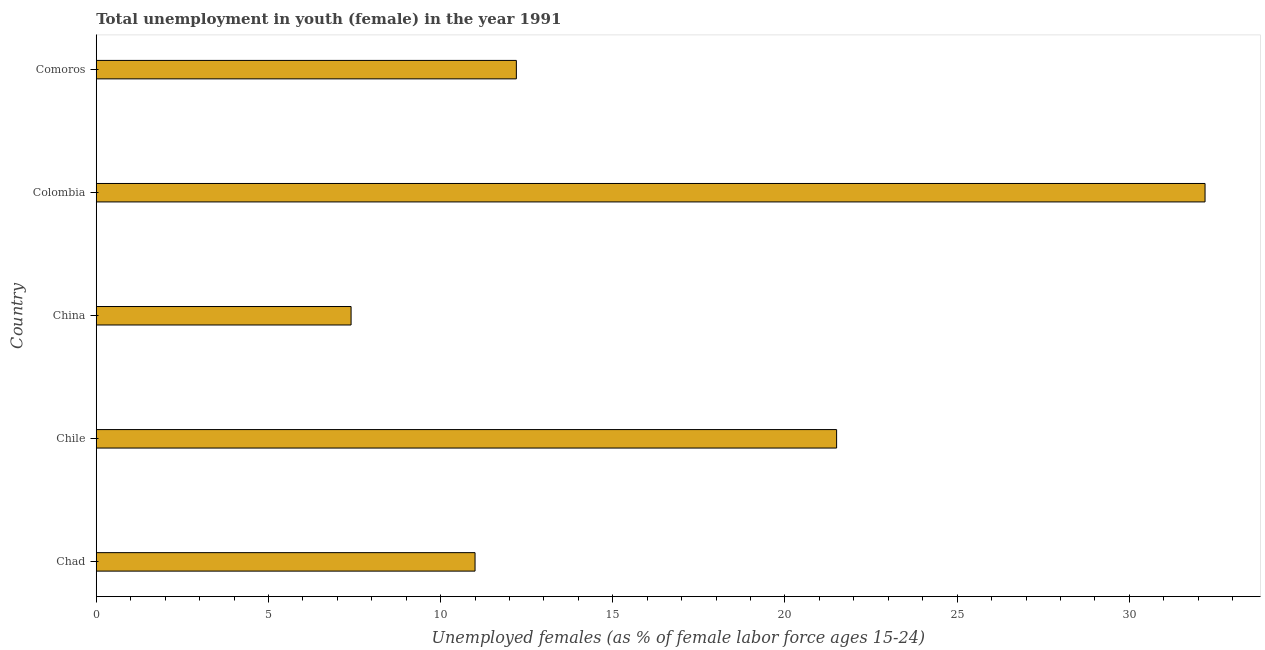Does the graph contain any zero values?
Provide a succinct answer. No. Does the graph contain grids?
Offer a very short reply. No. What is the title of the graph?
Offer a terse response. Total unemployment in youth (female) in the year 1991. What is the label or title of the X-axis?
Your answer should be compact. Unemployed females (as % of female labor force ages 15-24). What is the label or title of the Y-axis?
Ensure brevity in your answer.  Country. What is the unemployed female youth population in Comoros?
Your answer should be very brief. 12.2. Across all countries, what is the maximum unemployed female youth population?
Your response must be concise. 32.2. Across all countries, what is the minimum unemployed female youth population?
Ensure brevity in your answer.  7.4. In which country was the unemployed female youth population maximum?
Make the answer very short. Colombia. In which country was the unemployed female youth population minimum?
Provide a short and direct response. China. What is the sum of the unemployed female youth population?
Your answer should be very brief. 84.3. What is the average unemployed female youth population per country?
Offer a terse response. 16.86. What is the median unemployed female youth population?
Offer a terse response. 12.2. What is the ratio of the unemployed female youth population in China to that in Comoros?
Your answer should be compact. 0.61. Is the sum of the unemployed female youth population in Chad and China greater than the maximum unemployed female youth population across all countries?
Offer a terse response. No. What is the difference between the highest and the lowest unemployed female youth population?
Offer a terse response. 24.8. In how many countries, is the unemployed female youth population greater than the average unemployed female youth population taken over all countries?
Offer a terse response. 2. How many bars are there?
Your answer should be compact. 5. Are all the bars in the graph horizontal?
Your answer should be compact. Yes. How many countries are there in the graph?
Keep it short and to the point. 5. What is the Unemployed females (as % of female labor force ages 15-24) in Chile?
Offer a very short reply. 21.5. What is the Unemployed females (as % of female labor force ages 15-24) in China?
Keep it short and to the point. 7.4. What is the Unemployed females (as % of female labor force ages 15-24) in Colombia?
Ensure brevity in your answer.  32.2. What is the Unemployed females (as % of female labor force ages 15-24) in Comoros?
Your response must be concise. 12.2. What is the difference between the Unemployed females (as % of female labor force ages 15-24) in Chad and Colombia?
Provide a short and direct response. -21.2. What is the difference between the Unemployed females (as % of female labor force ages 15-24) in Chile and China?
Keep it short and to the point. 14.1. What is the difference between the Unemployed females (as % of female labor force ages 15-24) in Chile and Colombia?
Your answer should be compact. -10.7. What is the difference between the Unemployed females (as % of female labor force ages 15-24) in China and Colombia?
Provide a short and direct response. -24.8. What is the difference between the Unemployed females (as % of female labor force ages 15-24) in China and Comoros?
Offer a very short reply. -4.8. What is the difference between the Unemployed females (as % of female labor force ages 15-24) in Colombia and Comoros?
Your answer should be very brief. 20. What is the ratio of the Unemployed females (as % of female labor force ages 15-24) in Chad to that in Chile?
Offer a terse response. 0.51. What is the ratio of the Unemployed females (as % of female labor force ages 15-24) in Chad to that in China?
Offer a very short reply. 1.49. What is the ratio of the Unemployed females (as % of female labor force ages 15-24) in Chad to that in Colombia?
Give a very brief answer. 0.34. What is the ratio of the Unemployed females (as % of female labor force ages 15-24) in Chad to that in Comoros?
Provide a short and direct response. 0.9. What is the ratio of the Unemployed females (as % of female labor force ages 15-24) in Chile to that in China?
Keep it short and to the point. 2.9. What is the ratio of the Unemployed females (as % of female labor force ages 15-24) in Chile to that in Colombia?
Provide a succinct answer. 0.67. What is the ratio of the Unemployed females (as % of female labor force ages 15-24) in Chile to that in Comoros?
Give a very brief answer. 1.76. What is the ratio of the Unemployed females (as % of female labor force ages 15-24) in China to that in Colombia?
Ensure brevity in your answer.  0.23. What is the ratio of the Unemployed females (as % of female labor force ages 15-24) in China to that in Comoros?
Provide a succinct answer. 0.61. What is the ratio of the Unemployed females (as % of female labor force ages 15-24) in Colombia to that in Comoros?
Keep it short and to the point. 2.64. 